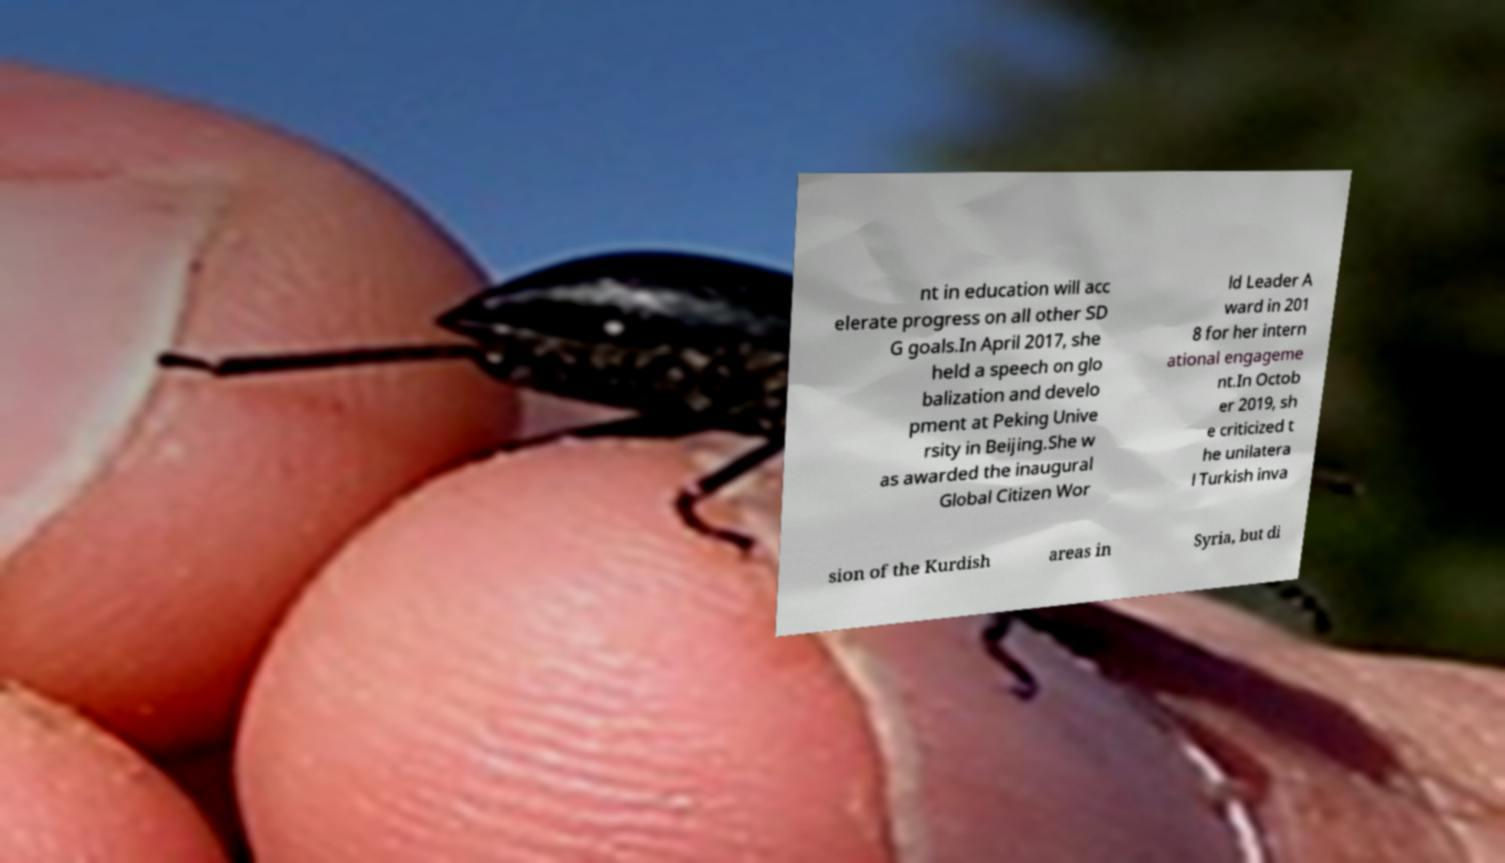Can you accurately transcribe the text from the provided image for me? nt in education will acc elerate progress on all other SD G goals.In April 2017, she held a speech on glo balization and develo pment at Peking Unive rsity in Beijing.She w as awarded the inaugural Global Citizen Wor ld Leader A ward in 201 8 for her intern ational engageme nt.In Octob er 2019, sh e criticized t he unilatera l Turkish inva sion of the Kurdish areas in Syria, but di 